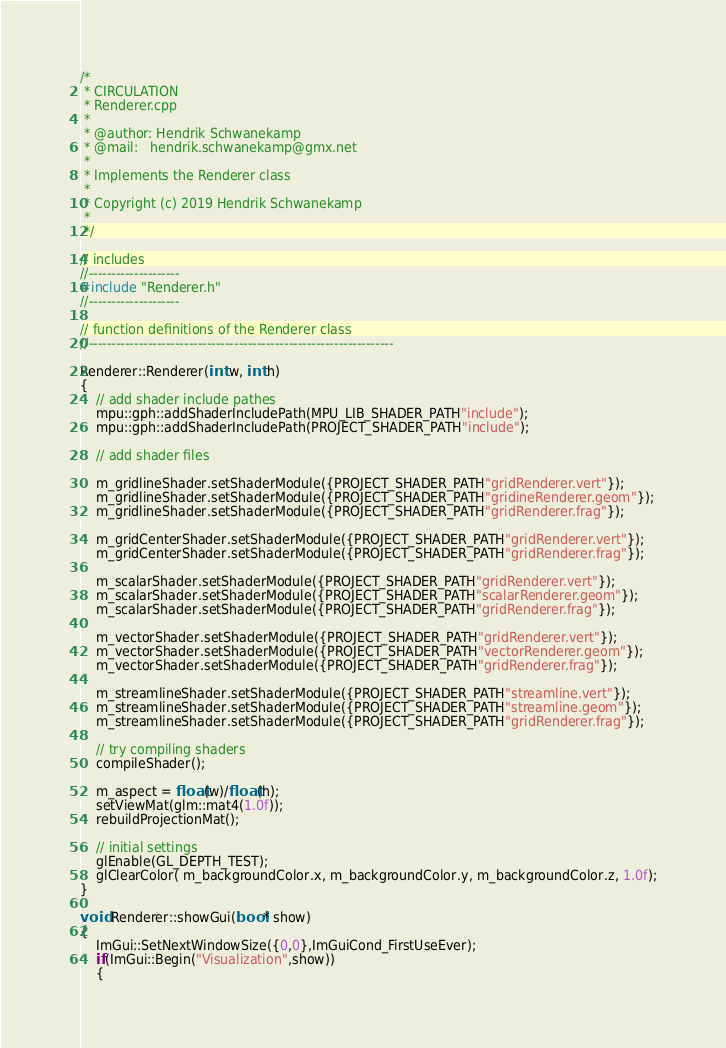<code> <loc_0><loc_0><loc_500><loc_500><_Cuda_>/*
 * CIRCULATION
 * Renderer.cpp
 *
 * @author: Hendrik Schwanekamp
 * @mail:   hendrik.schwanekamp@gmx.net
 *
 * Implements the Renderer class
 *
 * Copyright (c) 2019 Hendrik Schwanekamp
 *
 */

// includes
//--------------------
#include "Renderer.h"
//--------------------

// function definitions of the Renderer class
//-------------------------------------------------------------------

Renderer::Renderer(int w, int h)
{
    // add shader include pathes
    mpu::gph::addShaderIncludePath(MPU_LIB_SHADER_PATH"include");
    mpu::gph::addShaderIncludePath(PROJECT_SHADER_PATH"include");

    // add shader files

    m_gridlineShader.setShaderModule({PROJECT_SHADER_PATH"gridRenderer.vert"});
    m_gridlineShader.setShaderModule({PROJECT_SHADER_PATH"gridineRenderer.geom"});
    m_gridlineShader.setShaderModule({PROJECT_SHADER_PATH"gridRenderer.frag"});

    m_gridCenterShader.setShaderModule({PROJECT_SHADER_PATH"gridRenderer.vert"});
    m_gridCenterShader.setShaderModule({PROJECT_SHADER_PATH"gridRenderer.frag"});

    m_scalarShader.setShaderModule({PROJECT_SHADER_PATH"gridRenderer.vert"});
    m_scalarShader.setShaderModule({PROJECT_SHADER_PATH"scalarRenderer.geom"});
    m_scalarShader.setShaderModule({PROJECT_SHADER_PATH"gridRenderer.frag"});

    m_vectorShader.setShaderModule({PROJECT_SHADER_PATH"gridRenderer.vert"});
    m_vectorShader.setShaderModule({PROJECT_SHADER_PATH"vectorRenderer.geom"});
    m_vectorShader.setShaderModule({PROJECT_SHADER_PATH"gridRenderer.frag"});

    m_streamlineShader.setShaderModule({PROJECT_SHADER_PATH"streamline.vert"});
    m_streamlineShader.setShaderModule({PROJECT_SHADER_PATH"streamline.geom"});
    m_streamlineShader.setShaderModule({PROJECT_SHADER_PATH"gridRenderer.frag"});

    // try compiling shaders
    compileShader();

    m_aspect = float(w)/float(h);
    setViewMat(glm::mat4(1.0f));
    rebuildProjectionMat();

    // initial settings
    glEnable(GL_DEPTH_TEST);
    glClearColor( m_backgroundColor.x, m_backgroundColor.y, m_backgroundColor.z, 1.0f);
}

void Renderer::showGui(bool* show)
{
    ImGui::SetNextWindowSize({0,0},ImGuiCond_FirstUseEver);
    if(ImGui::Begin("Visualization",show))
    {</code> 